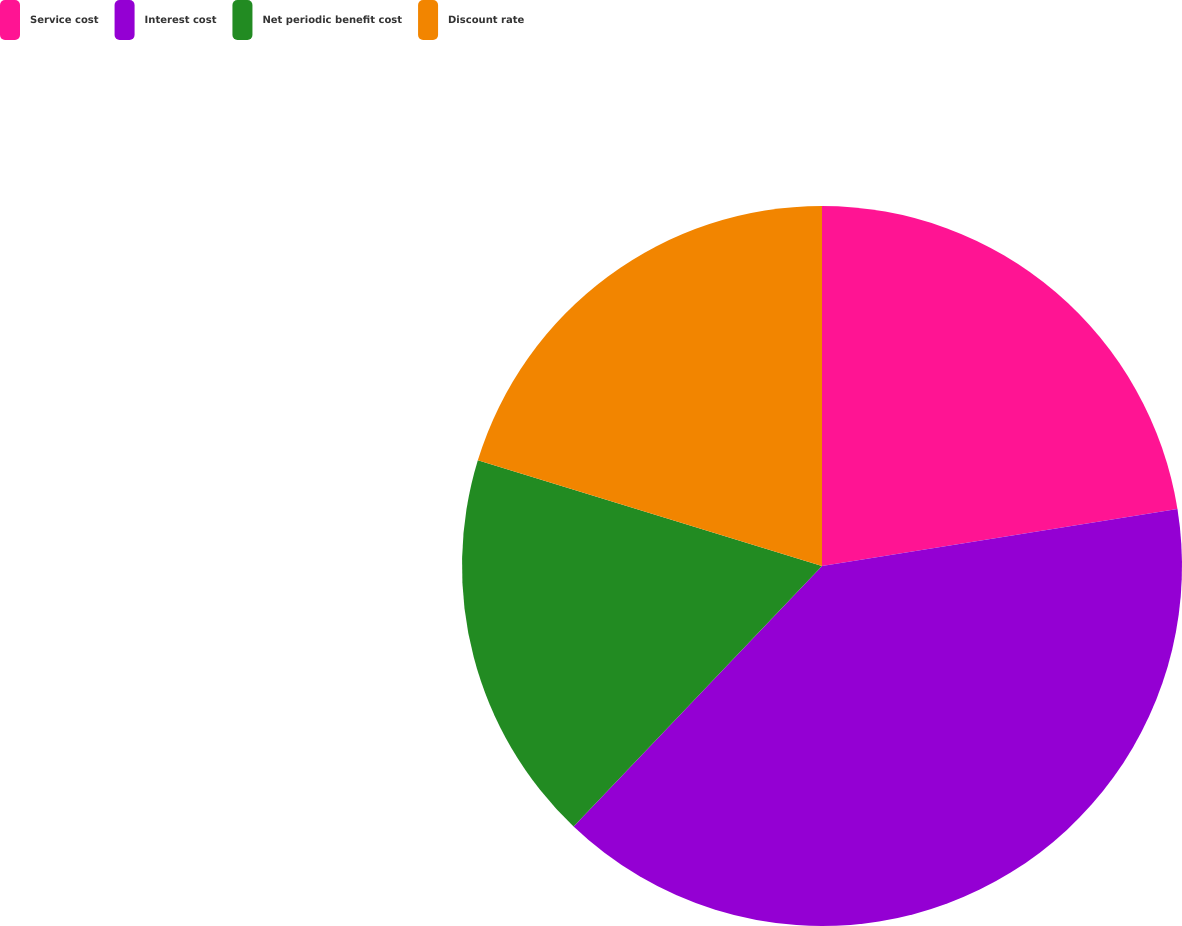Convert chart. <chart><loc_0><loc_0><loc_500><loc_500><pie_chart><fcel>Service cost<fcel>Interest cost<fcel>Net periodic benefit cost<fcel>Discount rate<nl><fcel>22.47%<fcel>39.65%<fcel>17.62%<fcel>20.26%<nl></chart> 